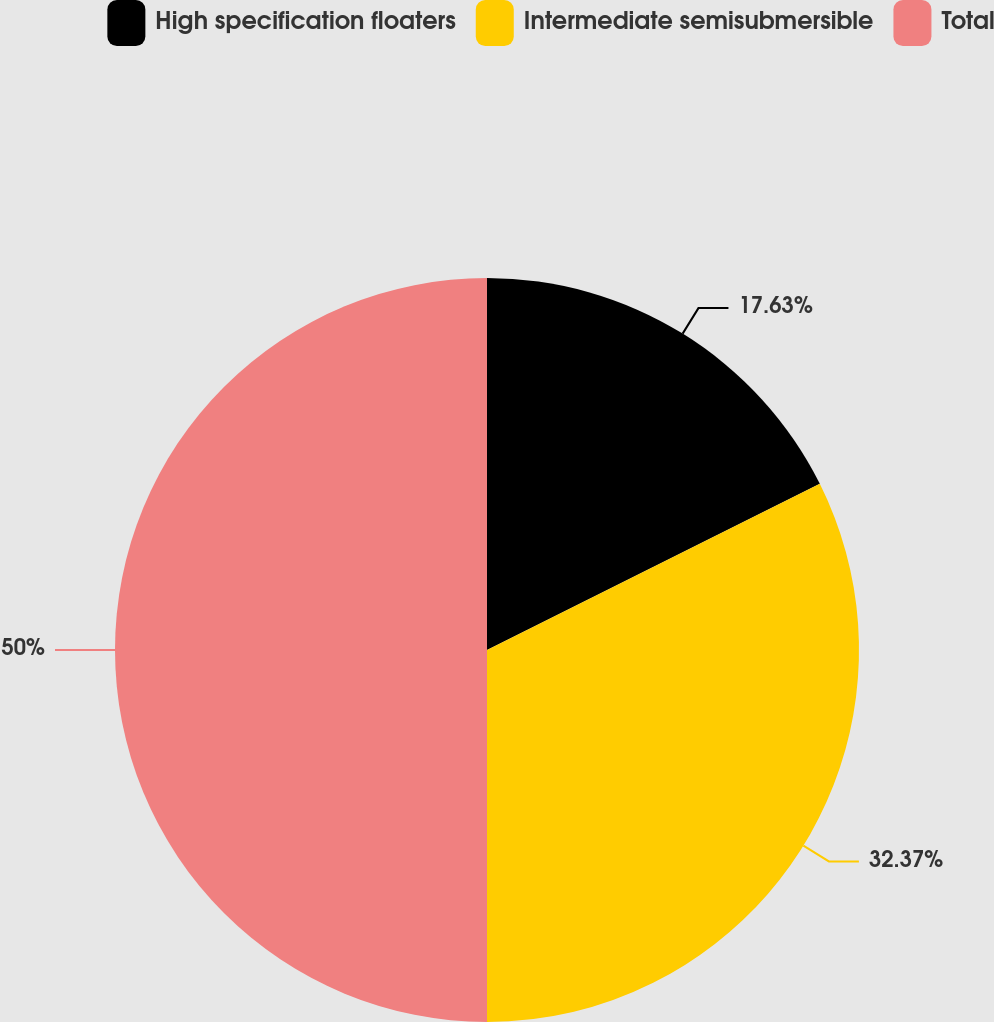Convert chart to OTSL. <chart><loc_0><loc_0><loc_500><loc_500><pie_chart><fcel>High specification floaters<fcel>Intermediate semisubmersible<fcel>Total<nl><fcel>17.63%<fcel>32.37%<fcel>50.0%<nl></chart> 